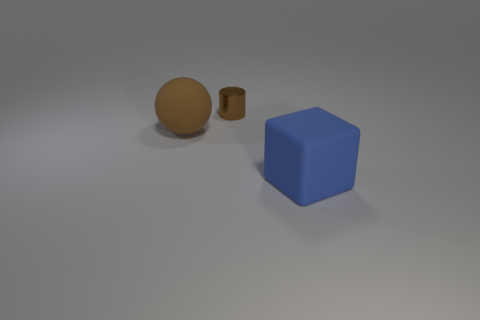What color is the cube that is the same material as the large brown ball? The cube that appears to share the same matte finish and color characteristics as the large brown ball is blue. 